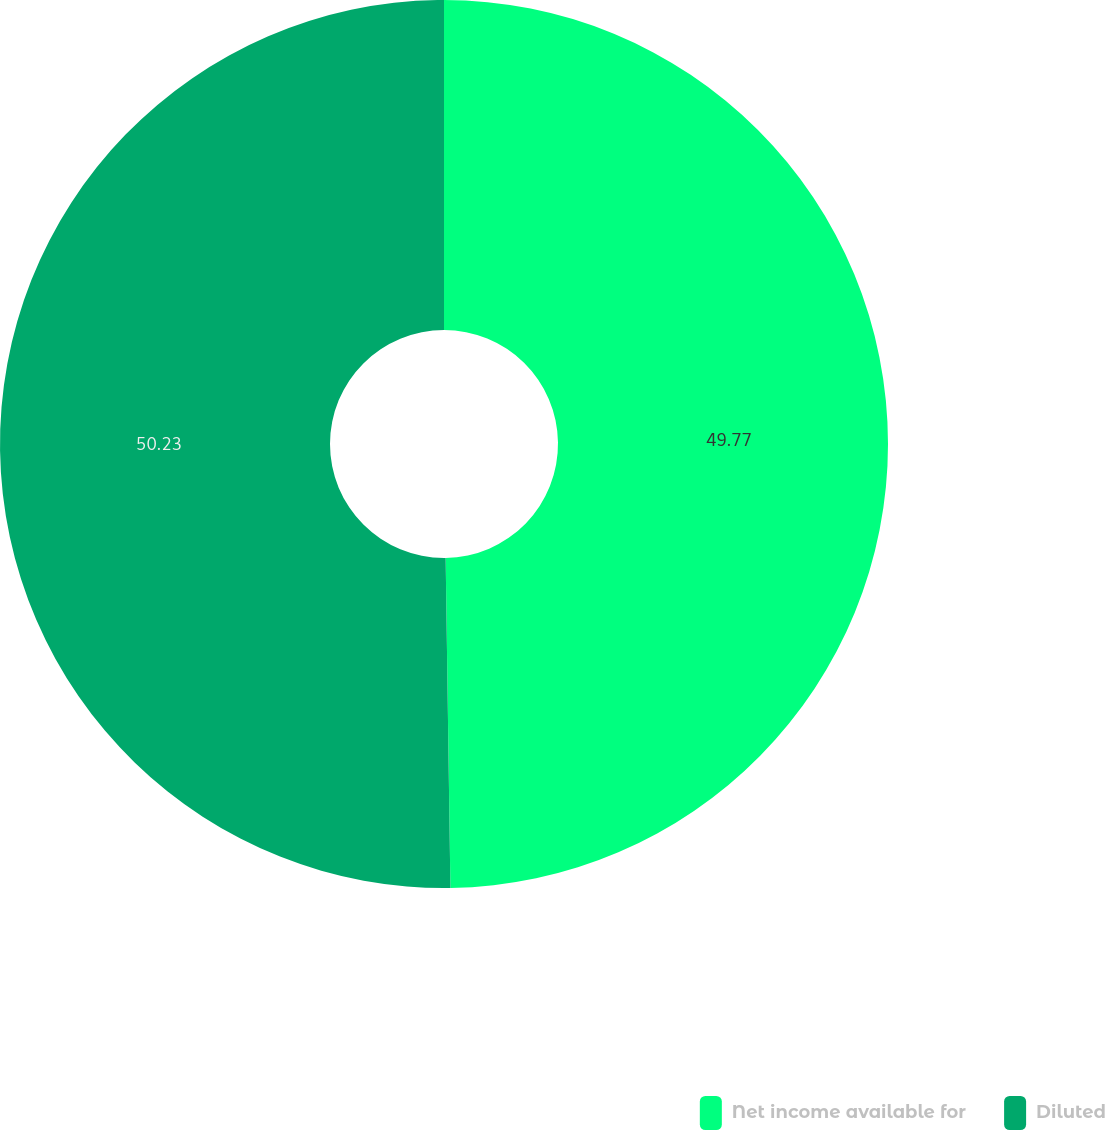Convert chart to OTSL. <chart><loc_0><loc_0><loc_500><loc_500><pie_chart><fcel>Net income available for<fcel>Diluted<nl><fcel>49.77%<fcel>50.23%<nl></chart> 